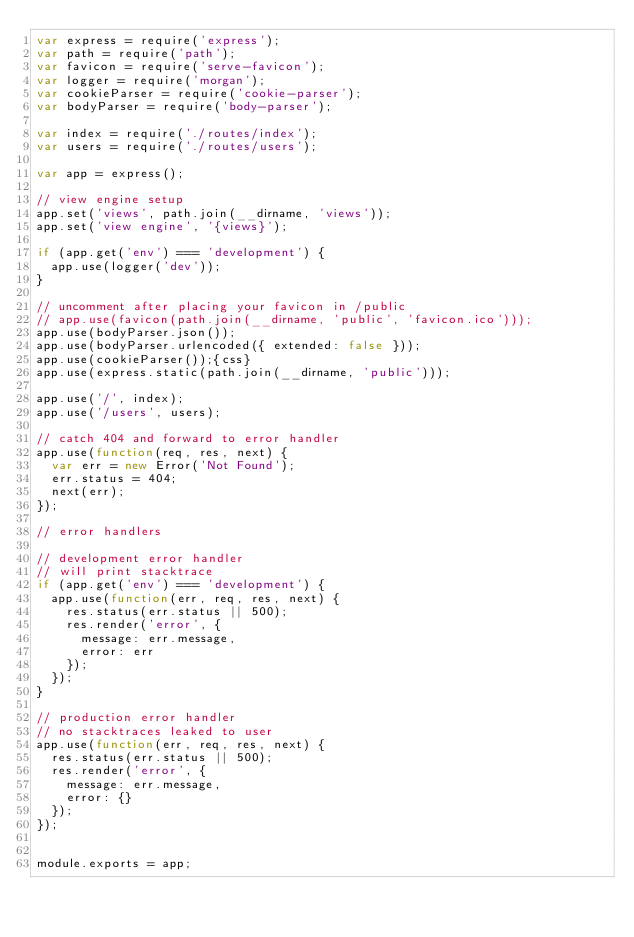Convert code to text. <code><loc_0><loc_0><loc_500><loc_500><_JavaScript_>var express = require('express');
var path = require('path');
var favicon = require('serve-favicon');
var logger = require('morgan');
var cookieParser = require('cookie-parser');
var bodyParser = require('body-parser');

var index = require('./routes/index');
var users = require('./routes/users');

var app = express();

// view engine setup
app.set('views', path.join(__dirname, 'views'));
app.set('view engine', '{views}');

if (app.get('env') === 'development') {
  app.use(logger('dev'));
}

// uncomment after placing your favicon in /public
// app.use(favicon(path.join(__dirname, 'public', 'favicon.ico')));
app.use(bodyParser.json());
app.use(bodyParser.urlencoded({ extended: false }));
app.use(cookieParser());{css}
app.use(express.static(path.join(__dirname, 'public')));

app.use('/', index);
app.use('/users', users);

// catch 404 and forward to error handler
app.use(function(req, res, next) {
  var err = new Error('Not Found');
  err.status = 404;
  next(err);
});

// error handlers

// development error handler
// will print stacktrace
if (app.get('env') === 'development') {
  app.use(function(err, req, res, next) {
    res.status(err.status || 500);
    res.render('error', {
      message: err.message,
      error: err
    });
  });
}

// production error handler
// no stacktraces leaked to user
app.use(function(err, req, res, next) {
  res.status(err.status || 500);
  res.render('error', {
    message: err.message,
    error: {}
  });
});


module.exports = app;
</code> 